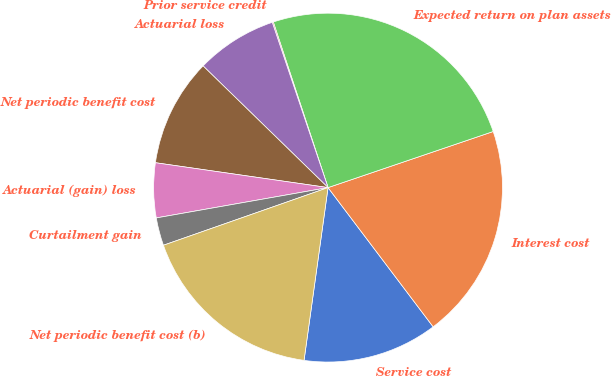<chart> <loc_0><loc_0><loc_500><loc_500><pie_chart><fcel>Service cost<fcel>Interest cost<fcel>Expected return on plan assets<fcel>Prior service credit<fcel>Actuarial loss<fcel>Net periodic benefit cost<fcel>Actuarial (gain) loss<fcel>Curtailment gain<fcel>Net periodic benefit cost (b)<nl><fcel>12.49%<fcel>19.92%<fcel>24.87%<fcel>0.1%<fcel>7.53%<fcel>10.01%<fcel>5.06%<fcel>2.58%<fcel>17.44%<nl></chart> 